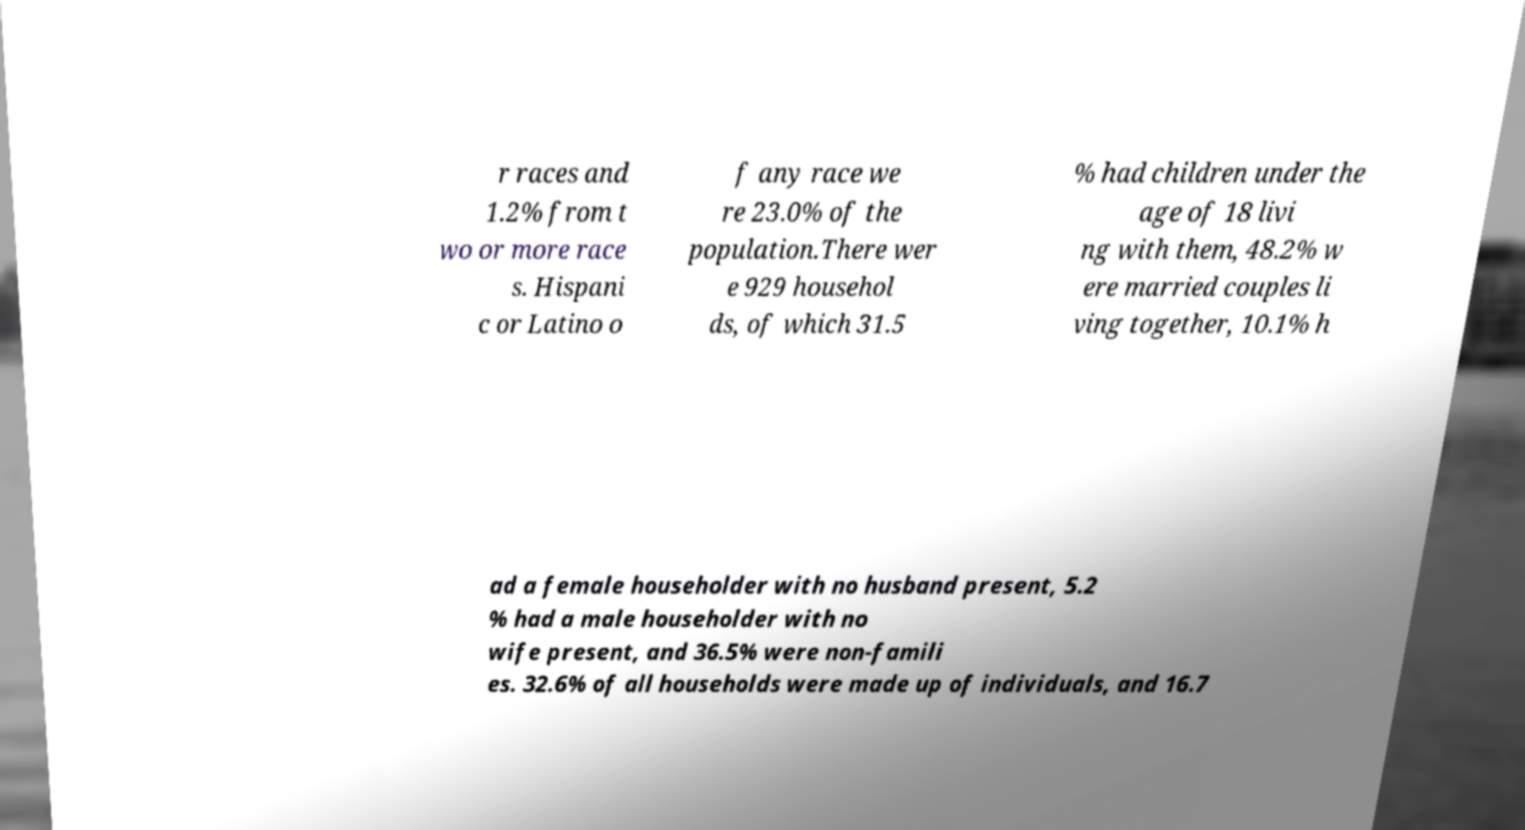There's text embedded in this image that I need extracted. Can you transcribe it verbatim? r races and 1.2% from t wo or more race s. Hispani c or Latino o f any race we re 23.0% of the population.There wer e 929 househol ds, of which 31.5 % had children under the age of 18 livi ng with them, 48.2% w ere married couples li ving together, 10.1% h ad a female householder with no husband present, 5.2 % had a male householder with no wife present, and 36.5% were non-famili es. 32.6% of all households were made up of individuals, and 16.7 